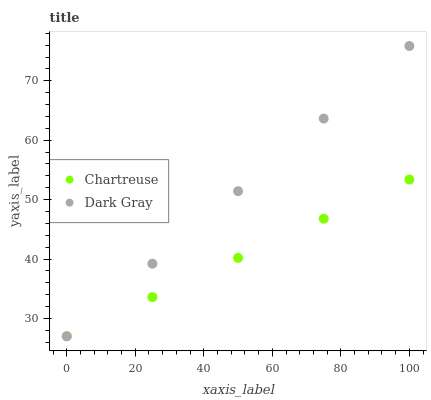Does Chartreuse have the minimum area under the curve?
Answer yes or no. Yes. Does Dark Gray have the maximum area under the curve?
Answer yes or no. Yes. Does Chartreuse have the maximum area under the curve?
Answer yes or no. No. Is Dark Gray the smoothest?
Answer yes or no. Yes. Is Chartreuse the roughest?
Answer yes or no. Yes. Does Dark Gray have the lowest value?
Answer yes or no. Yes. Does Dark Gray have the highest value?
Answer yes or no. Yes. Does Chartreuse have the highest value?
Answer yes or no. No. Does Dark Gray intersect Chartreuse?
Answer yes or no. Yes. Is Dark Gray less than Chartreuse?
Answer yes or no. No. Is Dark Gray greater than Chartreuse?
Answer yes or no. No. 